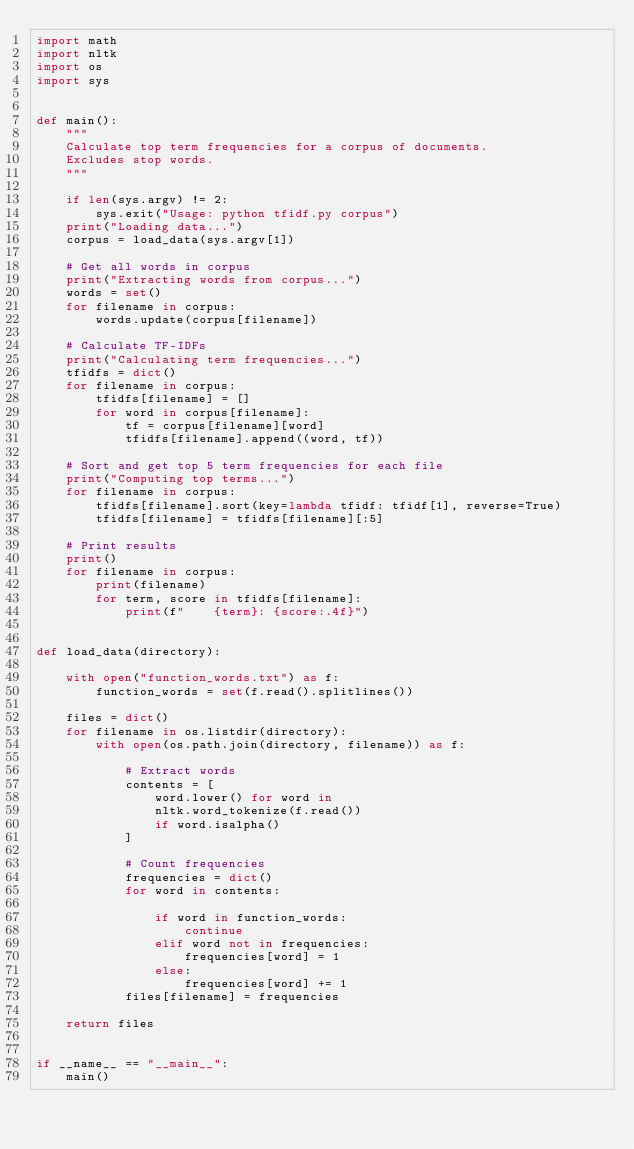<code> <loc_0><loc_0><loc_500><loc_500><_Python_>import math
import nltk
import os
import sys


def main():
    """
    Calculate top term frequencies for a corpus of documents.
    Excludes stop words.
    """

    if len(sys.argv) != 2:
        sys.exit("Usage: python tfidf.py corpus")
    print("Loading data...")
    corpus = load_data(sys.argv[1])

    # Get all words in corpus
    print("Extracting words from corpus...")
    words = set()
    for filename in corpus:
        words.update(corpus[filename])

    # Calculate TF-IDFs
    print("Calculating term frequencies...")
    tfidfs = dict()
    for filename in corpus:
        tfidfs[filename] = []
        for word in corpus[filename]:
            tf = corpus[filename][word]
            tfidfs[filename].append((word, tf))

    # Sort and get top 5 term frequencies for each file
    print("Computing top terms...")
    for filename in corpus:
        tfidfs[filename].sort(key=lambda tfidf: tfidf[1], reverse=True)
        tfidfs[filename] = tfidfs[filename][:5]

    # Print results
    print()
    for filename in corpus:
        print(filename)
        for term, score in tfidfs[filename]:
            print(f"    {term}: {score:.4f}")


def load_data(directory):

    with open("function_words.txt") as f:
        function_words = set(f.read().splitlines())

    files = dict()
    for filename in os.listdir(directory):
        with open(os.path.join(directory, filename)) as f:

            # Extract words
            contents = [
                word.lower() for word in
                nltk.word_tokenize(f.read())
                if word.isalpha()
            ]

            # Count frequencies
            frequencies = dict()
            for word in contents:

                if word in function_words:
                    continue
                elif word not in frequencies:
                    frequencies[word] = 1
                else:
                    frequencies[word] += 1
            files[filename] = frequencies

    return files


if __name__ == "__main__":
    main()
</code> 